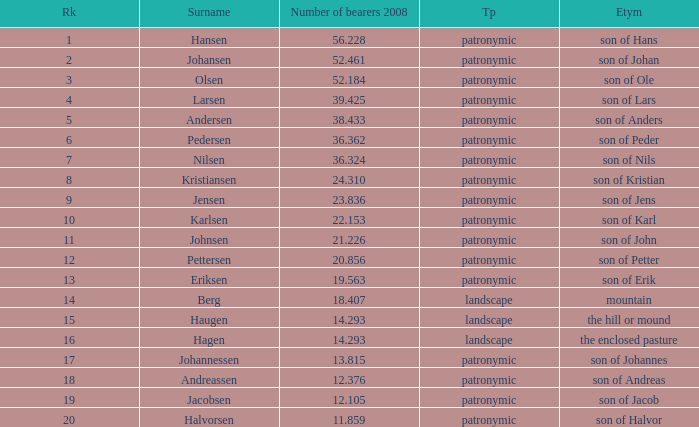What is the highest Number of Bearers 2008, when Surname is Hansen, and when Rank is less than 1? None. 